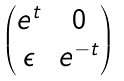Convert formula to latex. <formula><loc_0><loc_0><loc_500><loc_500>\begin{pmatrix} e ^ { t } & 0 \\ \epsilon & e ^ { - t } \end{pmatrix}</formula> 